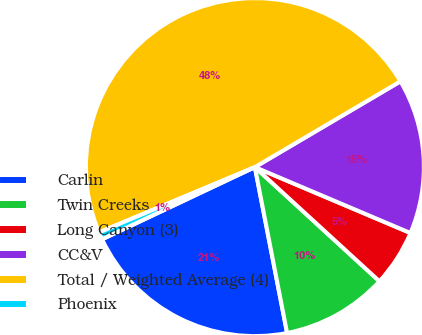<chart> <loc_0><loc_0><loc_500><loc_500><pie_chart><fcel>Carlin<fcel>Twin Creeks<fcel>Long Canyon (3)<fcel>CC&V<fcel>Total / Weighted Average (4)<fcel>Phoenix<nl><fcel>21.03%<fcel>10.14%<fcel>5.43%<fcel>14.85%<fcel>47.84%<fcel>0.71%<nl></chart> 